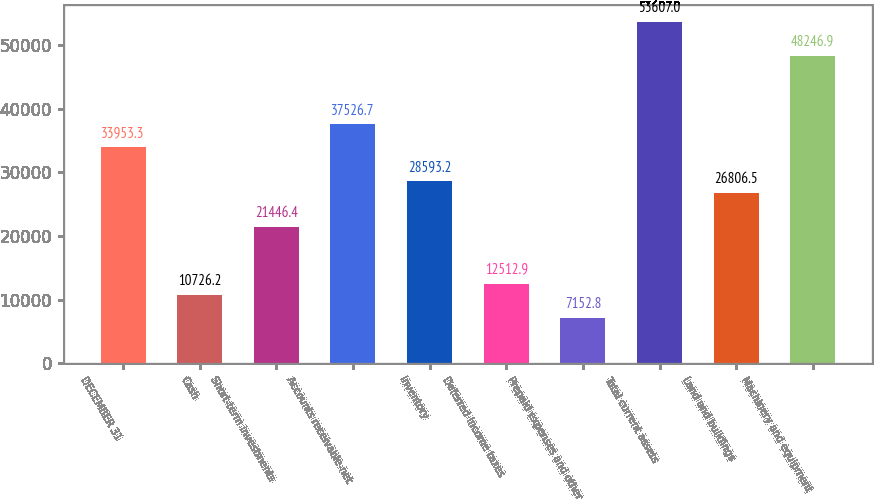<chart> <loc_0><loc_0><loc_500><loc_500><bar_chart><fcel>DECEMBER 31<fcel>Cash<fcel>Short-term investments<fcel>Accounts receivable-net<fcel>Inventory<fcel>Deferred income taxes<fcel>Prepaid expenses and other<fcel>Total current assets<fcel>Land and buildings<fcel>Machinery and equipment<nl><fcel>33953.3<fcel>10726.2<fcel>21446.4<fcel>37526.7<fcel>28593.2<fcel>12512.9<fcel>7152.8<fcel>53607<fcel>26806.5<fcel>48246.9<nl></chart> 